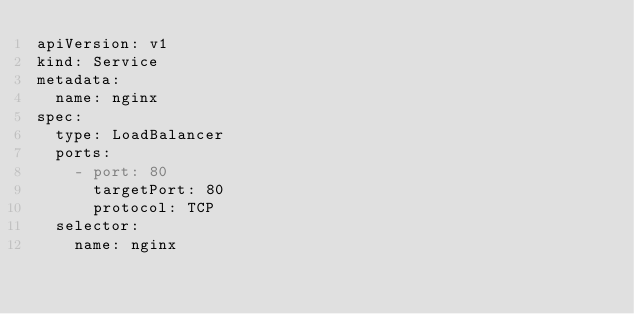Convert code to text. <code><loc_0><loc_0><loc_500><loc_500><_YAML_>apiVersion: v1
kind: Service
metadata:
  name: nginx
spec:
  type: LoadBalancer
  ports:
    - port: 80
      targetPort: 80
      protocol: TCP
  selector:
    name: nginx
</code> 